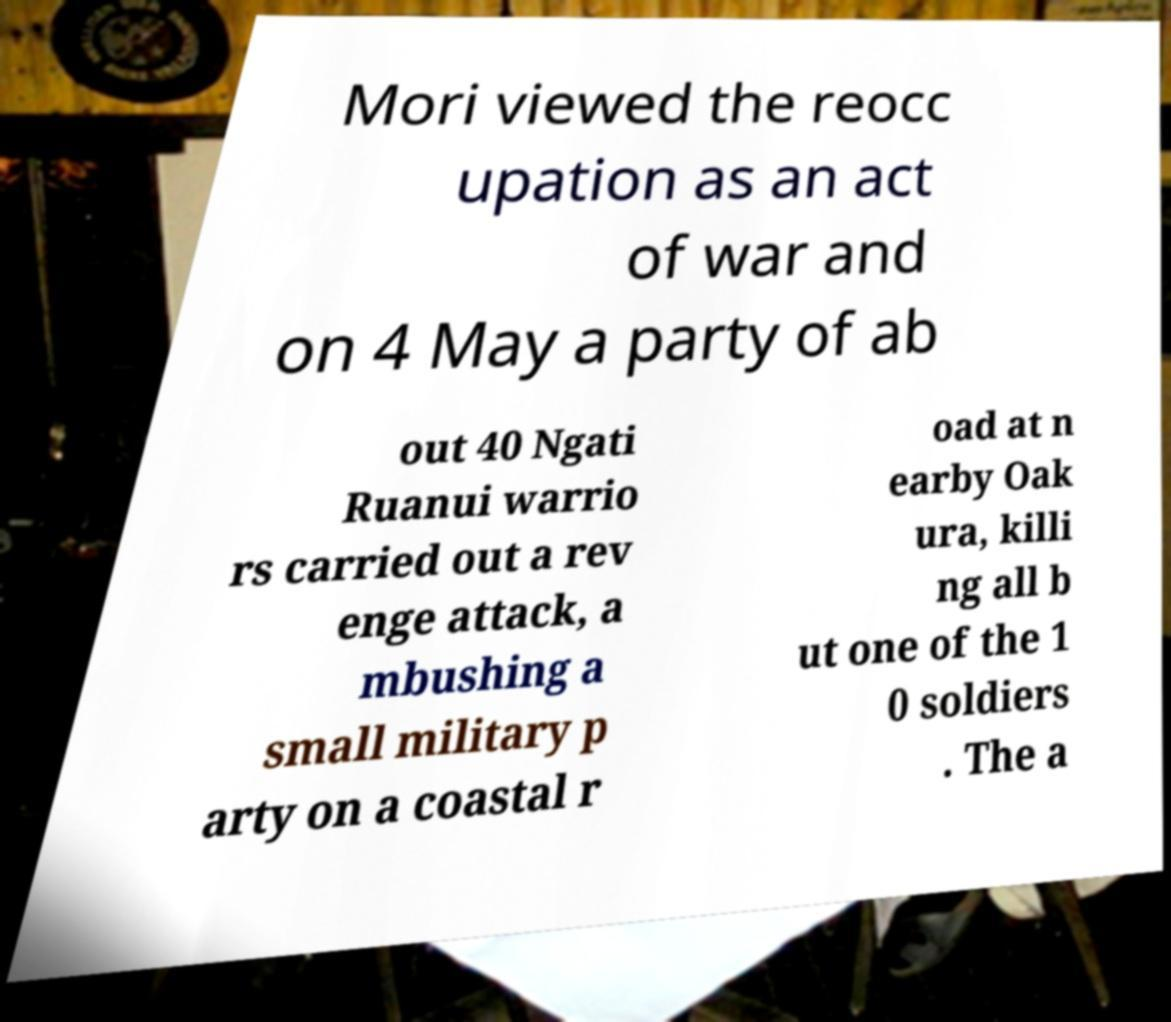Can you accurately transcribe the text from the provided image for me? Mori viewed the reocc upation as an act of war and on 4 May a party of ab out 40 Ngati Ruanui warrio rs carried out a rev enge attack, a mbushing a small military p arty on a coastal r oad at n earby Oak ura, killi ng all b ut one of the 1 0 soldiers . The a 